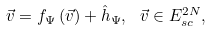<formula> <loc_0><loc_0><loc_500><loc_500>\vec { v } = f _ { \Psi } \left ( \vec { v } \right ) + \hat { h } _ { \Psi } , \text { } \vec { v } \in E _ { s c } ^ { 2 N } ,</formula> 